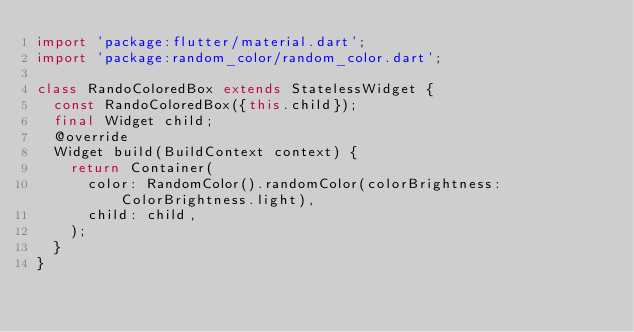Convert code to text. <code><loc_0><loc_0><loc_500><loc_500><_Dart_>import 'package:flutter/material.dart';
import 'package:random_color/random_color.dart';

class RandoColoredBox extends StatelessWidget {
  const RandoColoredBox({this.child});
  final Widget child;
  @override
  Widget build(BuildContext context) {
    return Container(
      color: RandomColor().randomColor(colorBrightness: ColorBrightness.light),
      child: child,
    );
  }
}
</code> 